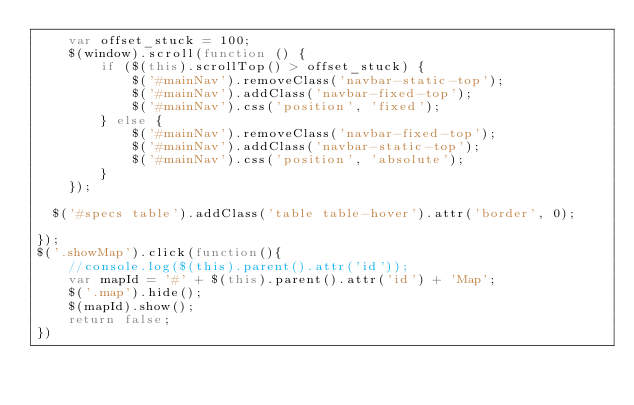Convert code to text. <code><loc_0><loc_0><loc_500><loc_500><_JavaScript_>    var offset_stuck = 100;
    $(window).scroll(function () {
        if ($(this).scrollTop() > offset_stuck) {
            $('#mainNav').removeClass('navbar-static-top');
            $('#mainNav').addClass('navbar-fixed-top');
            $('#mainNav').css('position', 'fixed');
        } else {  
            $('#mainNav').removeClass('navbar-fixed-top');
            $('#mainNav').addClass('navbar-static-top');
            $('#mainNav').css('position', 'absolute');
        }
    });
	
	$('#specs table').addClass('table table-hover').attr('border', 0);

});
$('.showMap').click(function(){
    //console.log($(this).parent().attr('id'));
    var mapId = '#' + $(this).parent().attr('id') + 'Map';
    $('.map').hide();
    $(mapId).show();
    return false;
})</code> 